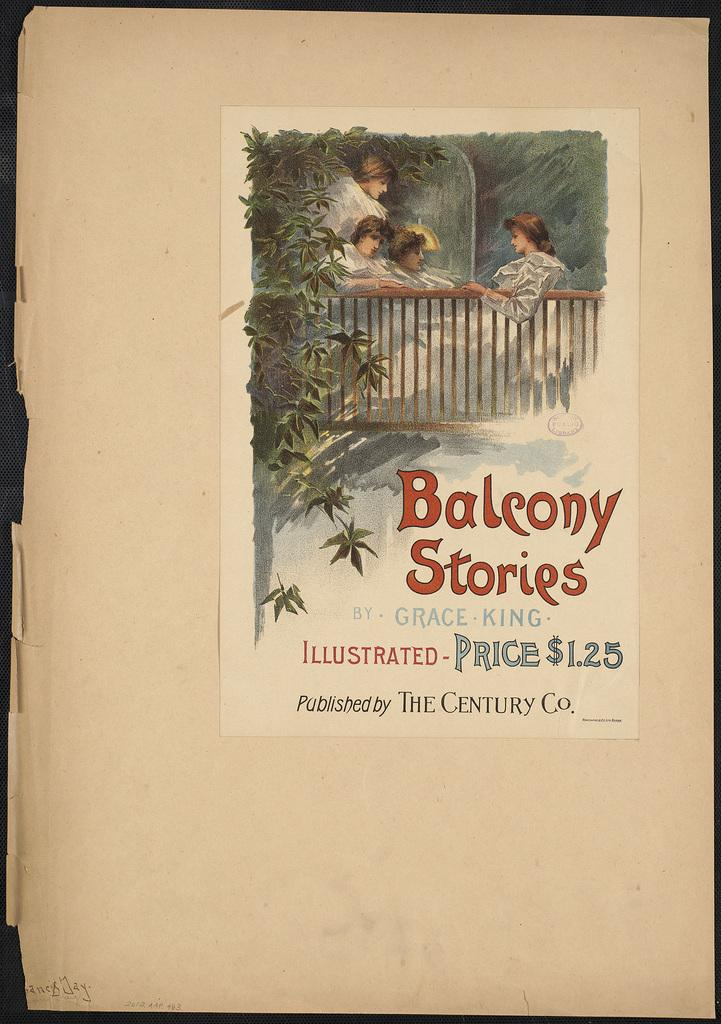<image>
Offer a succinct explanation of the picture presented. a book for $1.25 illustrating balcony stories on papere 